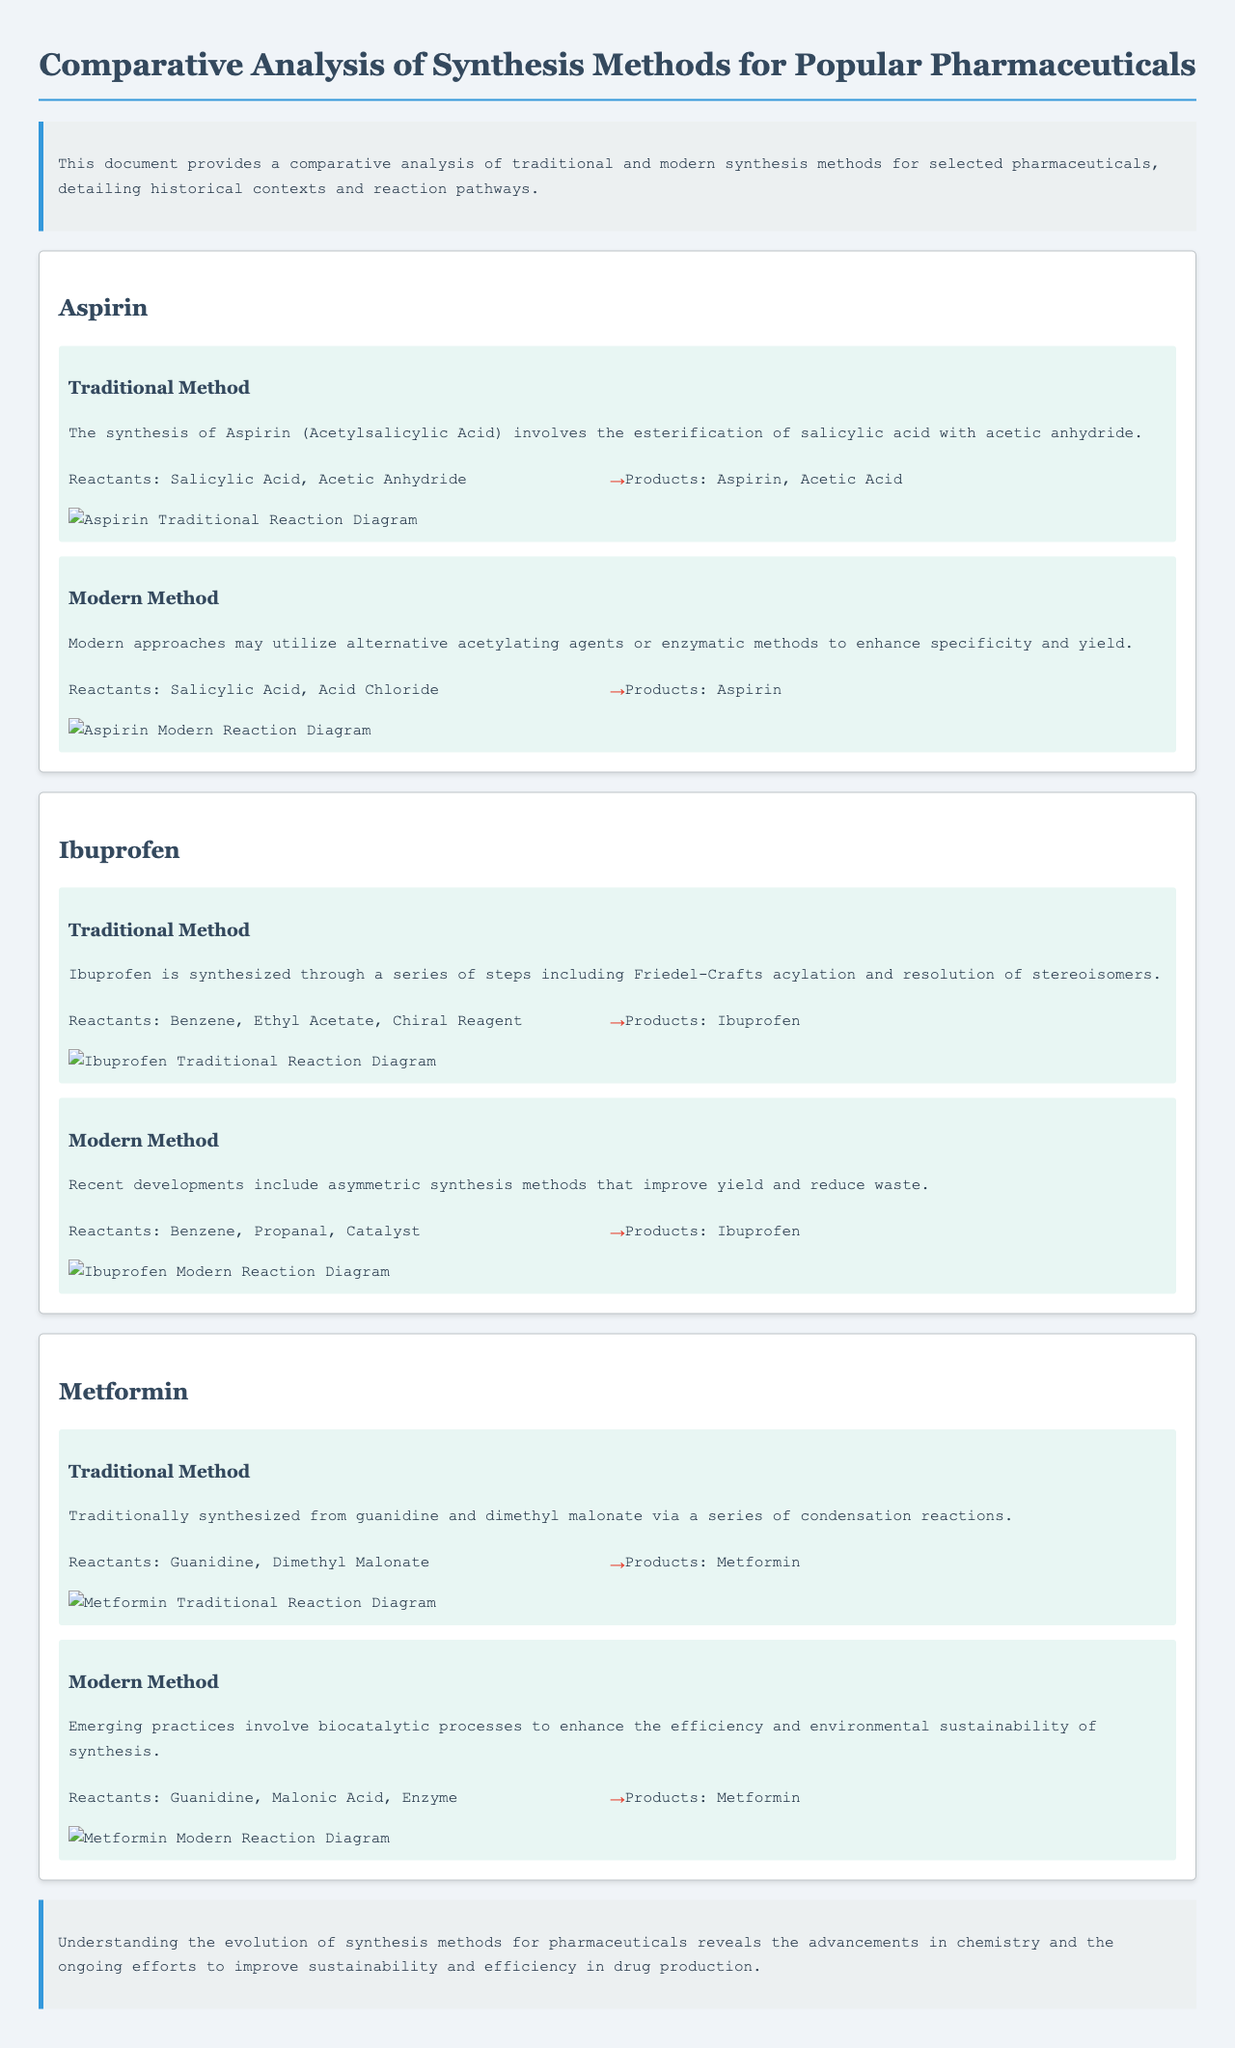what is the first reactant in the aspirin traditional method? The first reactant in the aspirin traditional method is salicylic acid.
Answer: salicylic acid how many synthesis methods are described for ibuprofen? There are two synthesis methods described for ibuprofen, one traditional and one modern.
Answer: two what is a key feature of modern synthesis methods for metformin? A key feature of modern synthesis methods for metformin is the use of biocatalytic processes.
Answer: biocatalytic processes what product is obtained from the traditional synthesis method of ibuprofen? The product obtained from the traditional synthesis method of ibuprofen is ibuprofen.
Answer: ibuprofen which pharmaceutical is synthesized by esterification of salicylic acid? Aspirin is synthesized by esterification of salicylic acid.
Answer: Aspirin what are the reactants used in the modern synthesis method of aspirin? The reactants used in the modern synthesis method of aspirin are salicylic acid and acid chloride.
Answer: salicylic acid and acid chloride how is the reaction pathway for traditional metformin synthesis illustrated? The reaction pathway for traditional metformin synthesis is illustrated with a diagram showing the transformation of reactants to products.
Answer: with a diagram what environmental improvement is noted in modern synthesis methods? Modern synthesis methods emphasize efficiency and environmental sustainability.
Answer: efficiency and environmental sustainability 